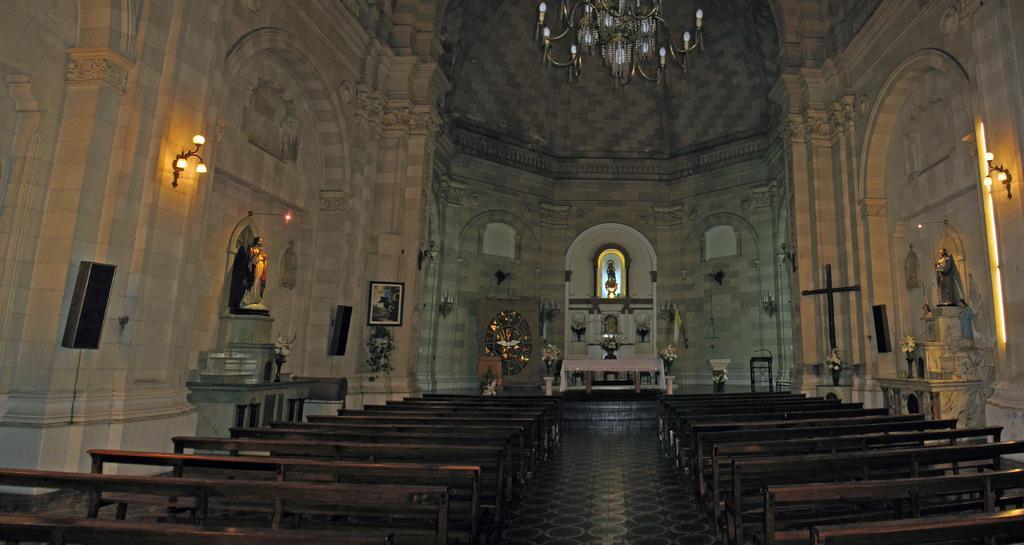Can you describe this image briefly? In this image few branches are on the floor. Middle of the image there is a bench. Both sides of it there are few flower vases. Beside the table there is a podium. Few idols are on the shelf. A picture frame is attached to the wall. Few lights and sound speakers are attached to the wall. Top of the image there is a chandelier. 